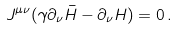Convert formula to latex. <formula><loc_0><loc_0><loc_500><loc_500>J ^ { \mu \nu } ( \gamma \partial _ { \nu } \bar { H } - \partial _ { \nu } H ) = 0 \, .</formula> 